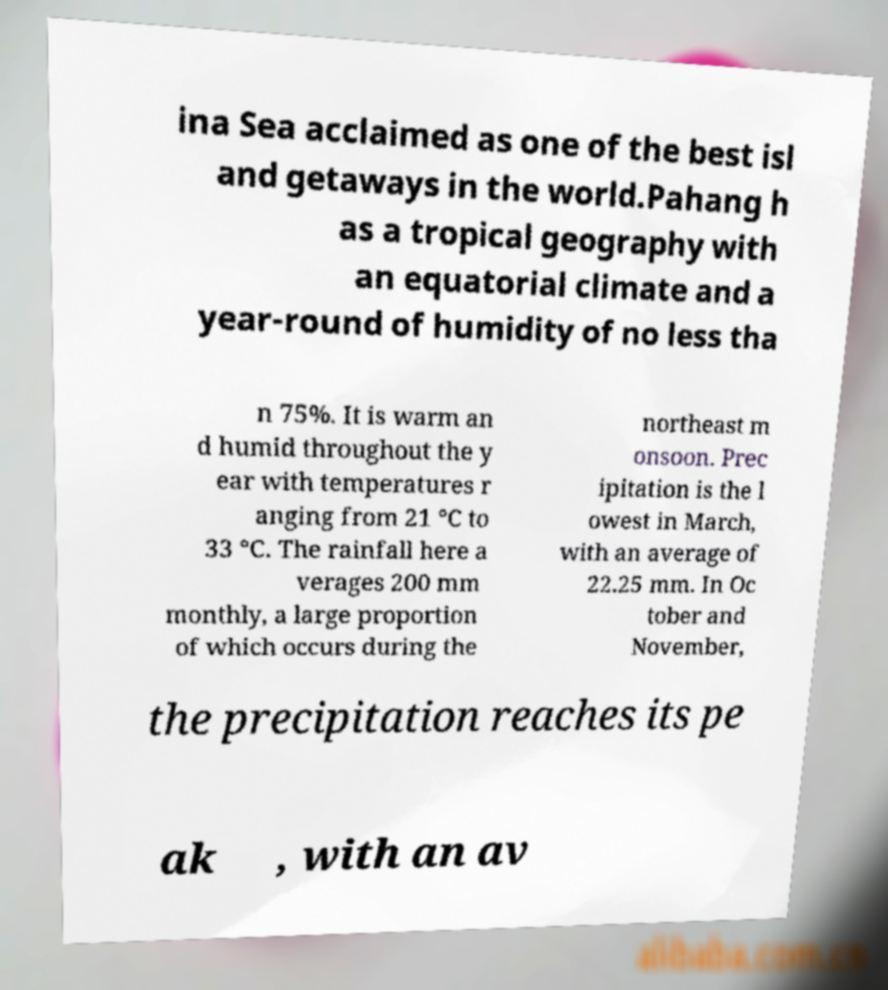Can you read and provide the text displayed in the image?This photo seems to have some interesting text. Can you extract and type it out for me? ina Sea acclaimed as one of the best isl and getaways in the world.Pahang h as a tropical geography with an equatorial climate and a year-round of humidity of no less tha n 75%. It is warm an d humid throughout the y ear with temperatures r anging from 21 °C to 33 °C. The rainfall here a verages 200 mm monthly, a large proportion of which occurs during the northeast m onsoon. Prec ipitation is the l owest in March, with an average of 22.25 mm. In Oc tober and November, the precipitation reaches its pe ak , with an av 